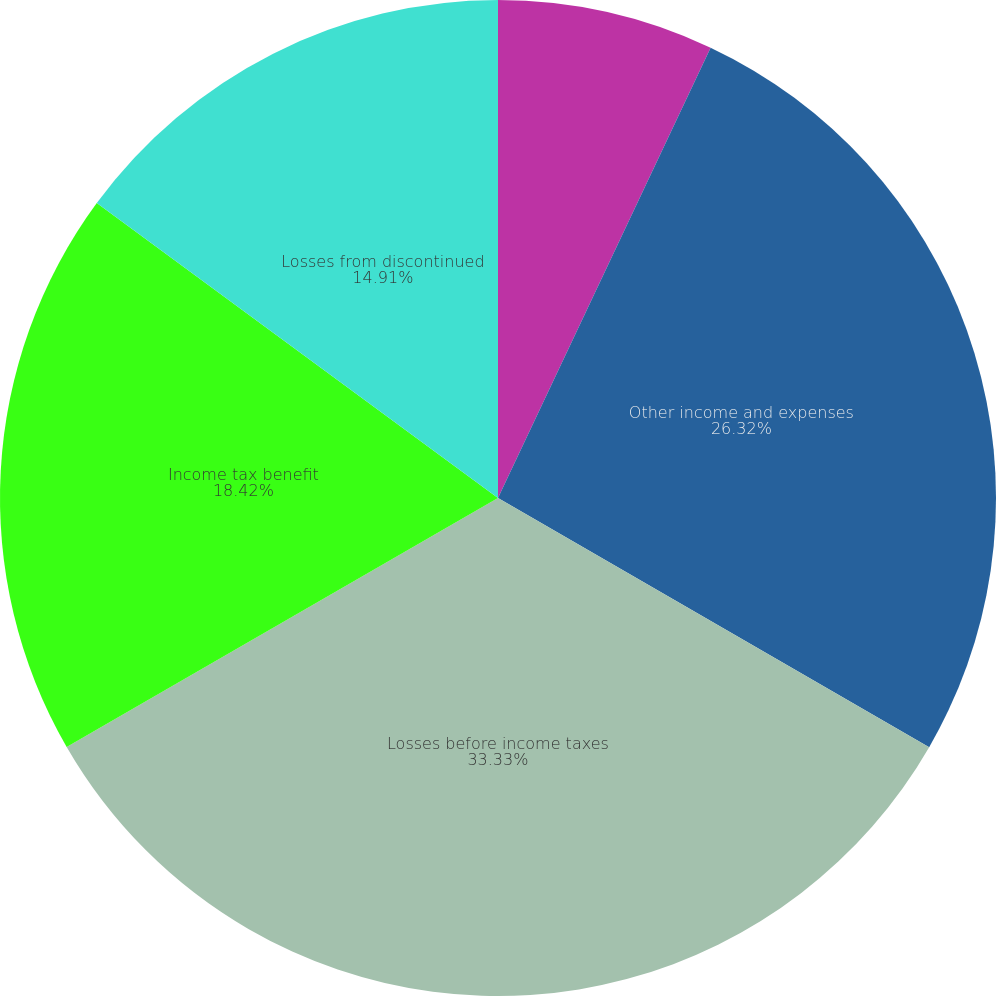Convert chart. <chart><loc_0><loc_0><loc_500><loc_500><pie_chart><fcel>Restaurant and marketing<fcel>Other income and expenses<fcel>Losses before income taxes<fcel>Income tax benefit<fcel>Losses from discontinued<nl><fcel>7.02%<fcel>26.32%<fcel>33.33%<fcel>18.42%<fcel>14.91%<nl></chart> 